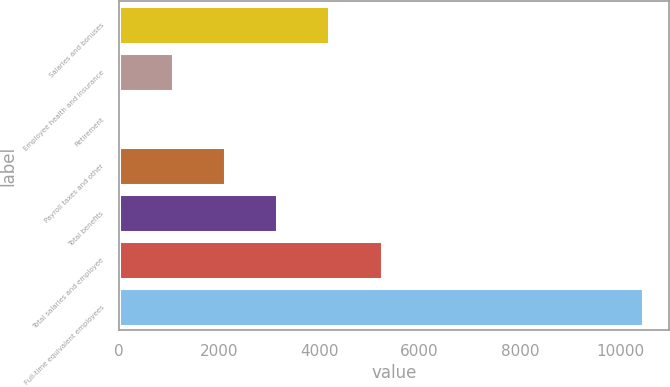Convert chart. <chart><loc_0><loc_0><loc_500><loc_500><bar_chart><fcel>Salaries and bonuses<fcel>Employee health and insurance<fcel>Retirement<fcel>Payroll taxes and other<fcel>Total benefits<fcel>Total salaries and employee<fcel>Full-time equivalent employees<nl><fcel>4204.2<fcel>1080.3<fcel>39<fcel>2121.6<fcel>3162.9<fcel>5245.5<fcel>10452<nl></chart> 